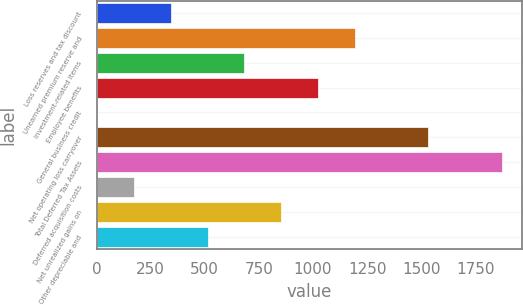Convert chart. <chart><loc_0><loc_0><loc_500><loc_500><bar_chart><fcel>Loss reserves and tax discount<fcel>Unearned premium reserve and<fcel>Investment-related items<fcel>Employee benefits<fcel>General business credit<fcel>Net operating loss carryover<fcel>Total Deferred Tax Assets<fcel>Deferred acquisition costs<fcel>Net unrealized gains on<fcel>Other depreciable and<nl><fcel>343<fcel>1193<fcel>683<fcel>1023<fcel>3<fcel>1533<fcel>1873<fcel>173<fcel>853<fcel>513<nl></chart> 